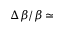Convert formula to latex. <formula><loc_0><loc_0><loc_500><loc_500>\Delta \beta / \beta \simeq</formula> 